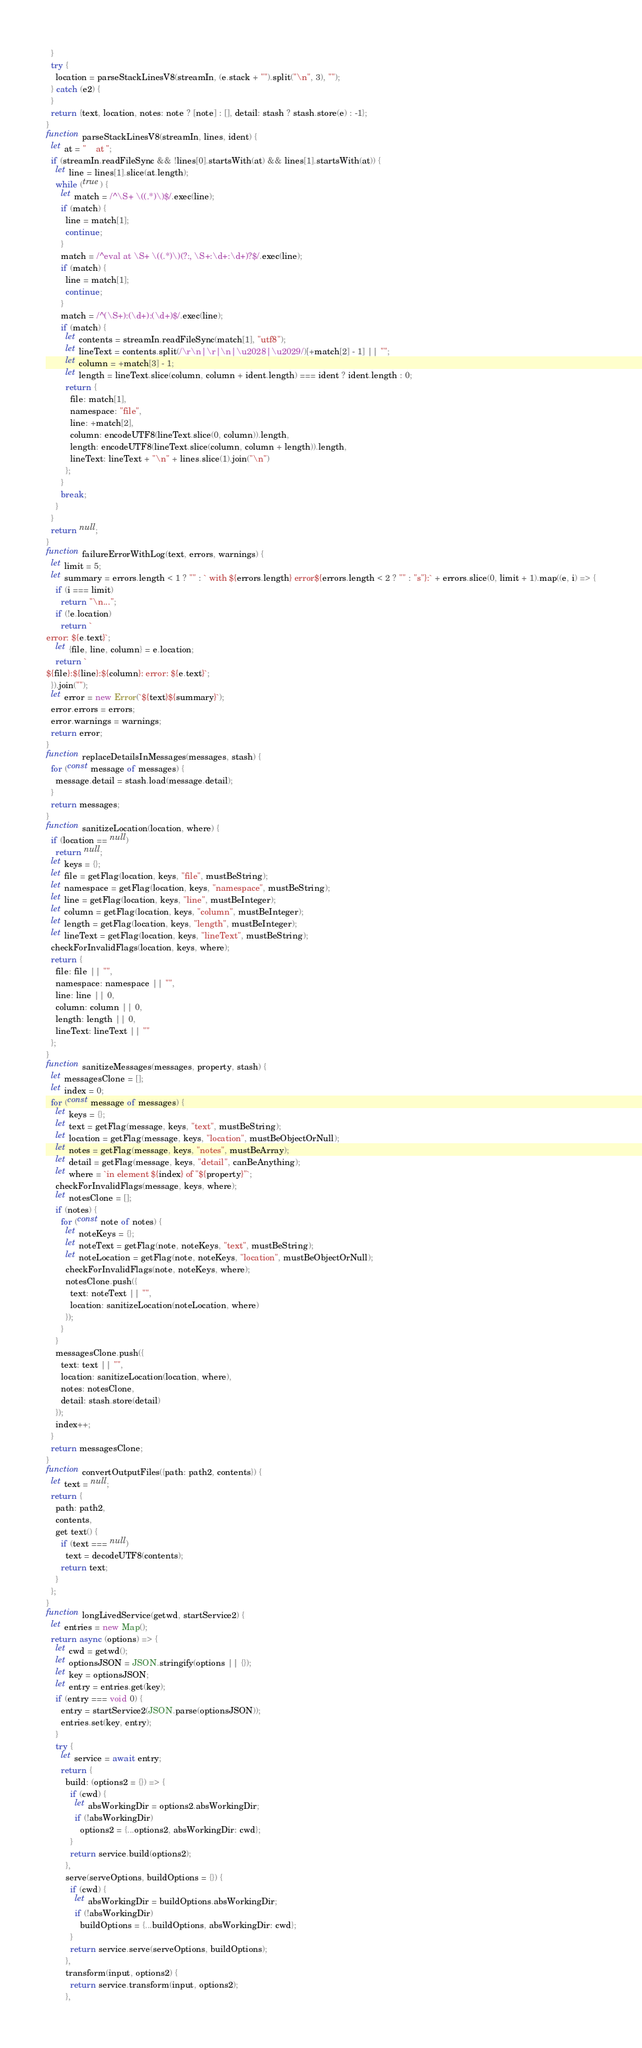<code> <loc_0><loc_0><loc_500><loc_500><_JavaScript_>  }
  try {
    location = parseStackLinesV8(streamIn, (e.stack + "").split("\n", 3), "");
  } catch (e2) {
  }
  return {text, location, notes: note ? [note] : [], detail: stash ? stash.store(e) : -1};
}
function parseStackLinesV8(streamIn, lines, ident) {
  let at = "    at ";
  if (streamIn.readFileSync && !lines[0].startsWith(at) && lines[1].startsWith(at)) {
    let line = lines[1].slice(at.length);
    while (true) {
      let match = /^\S+ \((.*)\)$/.exec(line);
      if (match) {
        line = match[1];
        continue;
      }
      match = /^eval at \S+ \((.*)\)(?:, \S+:\d+:\d+)?$/.exec(line);
      if (match) {
        line = match[1];
        continue;
      }
      match = /^(\S+):(\d+):(\d+)$/.exec(line);
      if (match) {
        let contents = streamIn.readFileSync(match[1], "utf8");
        let lineText = contents.split(/\r\n|\r|\n|\u2028|\u2029/)[+match[2] - 1] || "";
        let column = +match[3] - 1;
        let length = lineText.slice(column, column + ident.length) === ident ? ident.length : 0;
        return {
          file: match[1],
          namespace: "file",
          line: +match[2],
          column: encodeUTF8(lineText.slice(0, column)).length,
          length: encodeUTF8(lineText.slice(column, column + length)).length,
          lineText: lineText + "\n" + lines.slice(1).join("\n")
        };
      }
      break;
    }
  }
  return null;
}
function failureErrorWithLog(text, errors, warnings) {
  let limit = 5;
  let summary = errors.length < 1 ? "" : ` with ${errors.length} error${errors.length < 2 ? "" : "s"}:` + errors.slice(0, limit + 1).map((e, i) => {
    if (i === limit)
      return "\n...";
    if (!e.location)
      return `
error: ${e.text}`;
    let {file, line, column} = e.location;
    return `
${file}:${line}:${column}: error: ${e.text}`;
  }).join("");
  let error = new Error(`${text}${summary}`);
  error.errors = errors;
  error.warnings = warnings;
  return error;
}
function replaceDetailsInMessages(messages, stash) {
  for (const message of messages) {
    message.detail = stash.load(message.detail);
  }
  return messages;
}
function sanitizeLocation(location, where) {
  if (location == null)
    return null;
  let keys = {};
  let file = getFlag(location, keys, "file", mustBeString);
  let namespace = getFlag(location, keys, "namespace", mustBeString);
  let line = getFlag(location, keys, "line", mustBeInteger);
  let column = getFlag(location, keys, "column", mustBeInteger);
  let length = getFlag(location, keys, "length", mustBeInteger);
  let lineText = getFlag(location, keys, "lineText", mustBeString);
  checkForInvalidFlags(location, keys, where);
  return {
    file: file || "",
    namespace: namespace || "",
    line: line || 0,
    column: column || 0,
    length: length || 0,
    lineText: lineText || ""
  };
}
function sanitizeMessages(messages, property, stash) {
  let messagesClone = [];
  let index = 0;
  for (const message of messages) {
    let keys = {};
    let text = getFlag(message, keys, "text", mustBeString);
    let location = getFlag(message, keys, "location", mustBeObjectOrNull);
    let notes = getFlag(message, keys, "notes", mustBeArray);
    let detail = getFlag(message, keys, "detail", canBeAnything);
    let where = `in element ${index} of "${property}"`;
    checkForInvalidFlags(message, keys, where);
    let notesClone = [];
    if (notes) {
      for (const note of notes) {
        let noteKeys = {};
        let noteText = getFlag(note, noteKeys, "text", mustBeString);
        let noteLocation = getFlag(note, noteKeys, "location", mustBeObjectOrNull);
        checkForInvalidFlags(note, noteKeys, where);
        notesClone.push({
          text: noteText || "",
          location: sanitizeLocation(noteLocation, where)
        });
      }
    }
    messagesClone.push({
      text: text || "",
      location: sanitizeLocation(location, where),
      notes: notesClone,
      detail: stash.store(detail)
    });
    index++;
  }
  return messagesClone;
}
function convertOutputFiles({path: path2, contents}) {
  let text = null;
  return {
    path: path2,
    contents,
    get text() {
      if (text === null)
        text = decodeUTF8(contents);
      return text;
    }
  };
}
function longLivedService(getwd, startService2) {
  let entries = new Map();
  return async (options) => {
    let cwd = getwd();
    let optionsJSON = JSON.stringify(options || {});
    let key = optionsJSON;
    let entry = entries.get(key);
    if (entry === void 0) {
      entry = startService2(JSON.parse(optionsJSON));
      entries.set(key, entry);
    }
    try {
      let service = await entry;
      return {
        build: (options2 = {}) => {
          if (cwd) {
            let absWorkingDir = options2.absWorkingDir;
            if (!absWorkingDir)
              options2 = {...options2, absWorkingDir: cwd};
          }
          return service.build(options2);
        },
        serve(serveOptions, buildOptions = {}) {
          if (cwd) {
            let absWorkingDir = buildOptions.absWorkingDir;
            if (!absWorkingDir)
              buildOptions = {...buildOptions, absWorkingDir: cwd};
          }
          return service.serve(serveOptions, buildOptions);
        },
        transform(input, options2) {
          return service.transform(input, options2);
        },</code> 